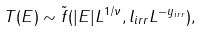Convert formula to latex. <formula><loc_0><loc_0><loc_500><loc_500>T ( E ) \sim \tilde { f } ( | E | L ^ { 1 / \nu } , l _ { i r r } L ^ { - y _ { i r r } } ) ,</formula> 